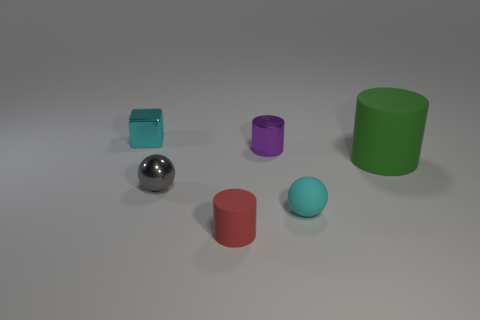Add 1 cyan rubber objects. How many objects exist? 7 Subtract all spheres. How many objects are left? 4 Subtract all tiny brown matte blocks. Subtract all purple things. How many objects are left? 5 Add 5 green cylinders. How many green cylinders are left? 6 Add 6 big blue metallic cylinders. How many big blue metallic cylinders exist? 6 Subtract 0 gray cylinders. How many objects are left? 6 